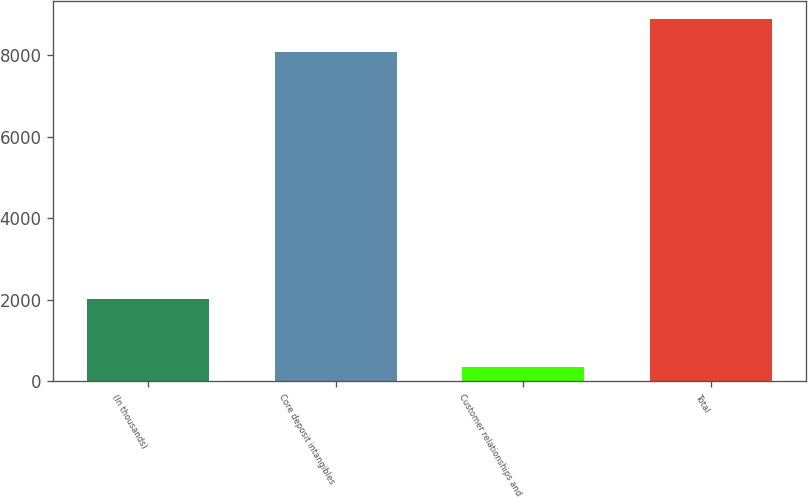Convert chart. <chart><loc_0><loc_0><loc_500><loc_500><bar_chart><fcel>(In thousands)<fcel>Core deposit intangibles<fcel>Customer relationships and<fcel>Total<nl><fcel>2016<fcel>8074<fcel>346<fcel>8881.4<nl></chart> 